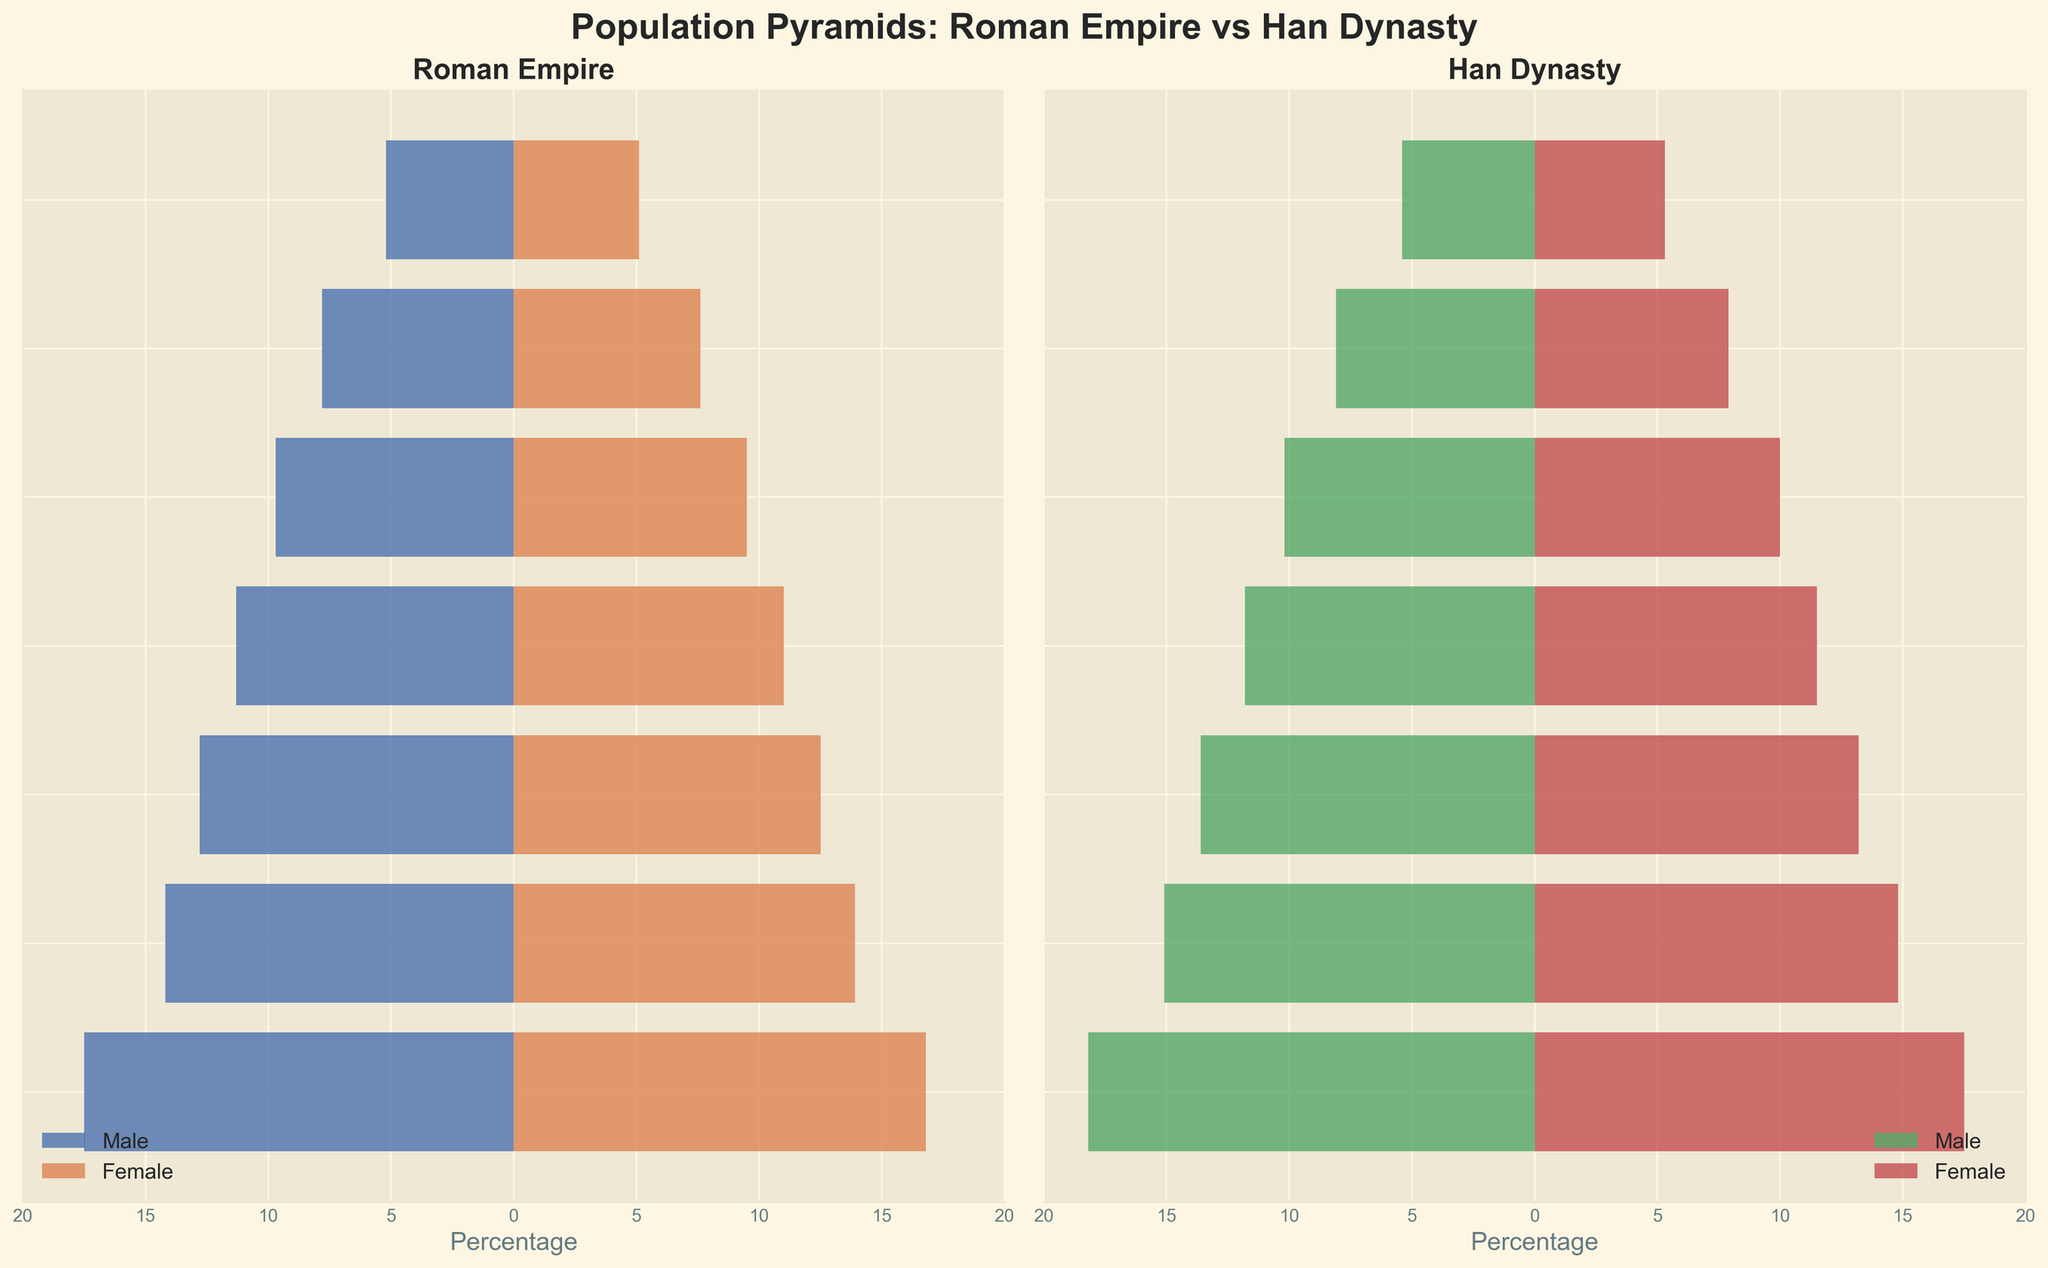What's the title of the figure? The title is located at the top of the figure and reads "Population Pyramids: Roman Empire vs Han Dynasty".
Answer: Population Pyramids: Roman Empire vs Han Dynasty What is the age group with the highest male population percentage in the Roman Empire? The Roman Empire's male data is depicted in a bar chart on the left. The 0-14 age group has the longest bar, indicating the highest percentage.
Answer: 0-14 Compare the female population percentages between the age group 25-34 in the Roman Empire and Han Dynasty. Which is higher? The female population percentages for 25-34 are on the bars labeled "25-34". For the Roman Empire, it's 12.5, and for the Han Dynasty, it's 13.2. Comparing the two, 13.2 is higher.
Answer: Han Dynasty How do the male and female populations of the age group 65+ in the Han Dynasty compare? The 65+ age group's bars for males and females in the Han Dynasty show 5.4 for males and 5.3 for females. The male percentage is slightly higher.
Answer: Male What percentage of the population in the age group 55-64 for the Han Dynasty is female? Find the 55-64 age group bars in the Han Dynasty section. The female bar for this age group extends to 7.9 percent.
Answer: 7.9 Summarize the overall trend in population distribution as age increases for both the Roman Empire and Han Dynasty. Observing both charts, we see that as age increases, the percentage of the population in each age group generally decreases for both males and females in both the Roman Empire and Han Dynasty.
Answer: Decreasing trend Compare the male population percentage in the age group 35-44 between the Roman Empire and Han Dynasty. Look at the bars for the male population in the age group 35-44 in both sections. The Roman Empire has 11.3% and the Han Dynasty has 11.8%. The Han Dynasty percentage is slightly higher.
Answer: Han Dynasty Which age group shows the smallest difference between male and female populations in the Roman Empire? By visually comparing the lengths of the male and female bars, the 65+ age group shows the smallest difference, as the male percentage is 5.2 and the female is 5.1.
Answer: 65+ What's the combined male population percentage of age group 15-24 for both civilizations? Add the male percentages of the 15-24 age group for both the Roman Empire (14.2) and Han Dynasty (15.1). The combined percentage is 14.2 + 15.1 = 29.3%.
Answer: 29.3 